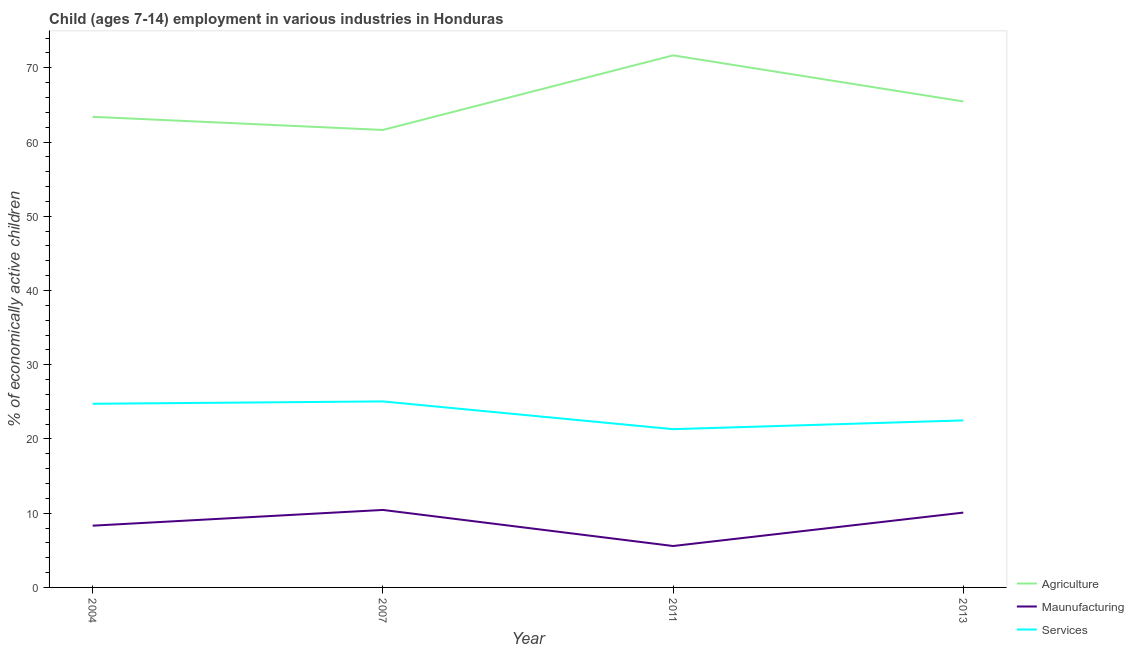How many different coloured lines are there?
Offer a very short reply. 3. Is the number of lines equal to the number of legend labels?
Your response must be concise. Yes. What is the percentage of economically active children in agriculture in 2011?
Offer a terse response. 71.68. Across all years, what is the maximum percentage of economically active children in manufacturing?
Your answer should be compact. 10.44. Across all years, what is the minimum percentage of economically active children in services?
Provide a succinct answer. 21.32. In which year was the percentage of economically active children in agriculture minimum?
Give a very brief answer. 2007. What is the total percentage of economically active children in agriculture in the graph?
Offer a very short reply. 262.18. What is the difference between the percentage of economically active children in services in 2007 and that in 2013?
Offer a terse response. 2.56. What is the difference between the percentage of economically active children in services in 2011 and the percentage of economically active children in agriculture in 2004?
Ensure brevity in your answer.  -42.08. What is the average percentage of economically active children in services per year?
Keep it short and to the point. 23.41. In the year 2011, what is the difference between the percentage of economically active children in manufacturing and percentage of economically active children in services?
Provide a succinct answer. -15.74. In how many years, is the percentage of economically active children in services greater than 18 %?
Ensure brevity in your answer.  4. What is the ratio of the percentage of economically active children in manufacturing in 2004 to that in 2011?
Ensure brevity in your answer.  1.49. What is the difference between the highest and the second highest percentage of economically active children in agriculture?
Provide a short and direct response. 6.21. What is the difference between the highest and the lowest percentage of economically active children in agriculture?
Ensure brevity in your answer.  10.05. In how many years, is the percentage of economically active children in manufacturing greater than the average percentage of economically active children in manufacturing taken over all years?
Your response must be concise. 2. Is it the case that in every year, the sum of the percentage of economically active children in agriculture and percentage of economically active children in manufacturing is greater than the percentage of economically active children in services?
Give a very brief answer. Yes. What is the difference between two consecutive major ticks on the Y-axis?
Make the answer very short. 10. Are the values on the major ticks of Y-axis written in scientific E-notation?
Your response must be concise. No. Does the graph contain any zero values?
Offer a terse response. No. How are the legend labels stacked?
Your response must be concise. Vertical. What is the title of the graph?
Make the answer very short. Child (ages 7-14) employment in various industries in Honduras. Does "Agriculture" appear as one of the legend labels in the graph?
Your response must be concise. Yes. What is the label or title of the Y-axis?
Your answer should be compact. % of economically active children. What is the % of economically active children of Agriculture in 2004?
Your response must be concise. 63.4. What is the % of economically active children of Maunufacturing in 2004?
Offer a terse response. 8.32. What is the % of economically active children of Services in 2004?
Ensure brevity in your answer.  24.74. What is the % of economically active children in Agriculture in 2007?
Give a very brief answer. 61.63. What is the % of economically active children in Maunufacturing in 2007?
Ensure brevity in your answer.  10.44. What is the % of economically active children of Services in 2007?
Provide a short and direct response. 25.06. What is the % of economically active children of Agriculture in 2011?
Your answer should be very brief. 71.68. What is the % of economically active children of Maunufacturing in 2011?
Provide a succinct answer. 5.58. What is the % of economically active children in Services in 2011?
Make the answer very short. 21.32. What is the % of economically active children in Agriculture in 2013?
Your answer should be compact. 65.47. What is the % of economically active children of Maunufacturing in 2013?
Offer a terse response. 10.08. Across all years, what is the maximum % of economically active children of Agriculture?
Keep it short and to the point. 71.68. Across all years, what is the maximum % of economically active children in Maunufacturing?
Your answer should be very brief. 10.44. Across all years, what is the maximum % of economically active children in Services?
Keep it short and to the point. 25.06. Across all years, what is the minimum % of economically active children of Agriculture?
Ensure brevity in your answer.  61.63. Across all years, what is the minimum % of economically active children of Maunufacturing?
Make the answer very short. 5.58. Across all years, what is the minimum % of economically active children of Services?
Provide a short and direct response. 21.32. What is the total % of economically active children of Agriculture in the graph?
Give a very brief answer. 262.18. What is the total % of economically active children in Maunufacturing in the graph?
Offer a very short reply. 34.42. What is the total % of economically active children of Services in the graph?
Ensure brevity in your answer.  93.62. What is the difference between the % of economically active children in Agriculture in 2004 and that in 2007?
Provide a short and direct response. 1.77. What is the difference between the % of economically active children in Maunufacturing in 2004 and that in 2007?
Make the answer very short. -2.12. What is the difference between the % of economically active children of Services in 2004 and that in 2007?
Provide a short and direct response. -0.32. What is the difference between the % of economically active children in Agriculture in 2004 and that in 2011?
Provide a short and direct response. -8.28. What is the difference between the % of economically active children in Maunufacturing in 2004 and that in 2011?
Make the answer very short. 2.74. What is the difference between the % of economically active children of Services in 2004 and that in 2011?
Keep it short and to the point. 3.42. What is the difference between the % of economically active children in Agriculture in 2004 and that in 2013?
Your answer should be very brief. -2.07. What is the difference between the % of economically active children of Maunufacturing in 2004 and that in 2013?
Keep it short and to the point. -1.76. What is the difference between the % of economically active children of Services in 2004 and that in 2013?
Make the answer very short. 2.24. What is the difference between the % of economically active children in Agriculture in 2007 and that in 2011?
Offer a very short reply. -10.05. What is the difference between the % of economically active children in Maunufacturing in 2007 and that in 2011?
Your response must be concise. 4.86. What is the difference between the % of economically active children of Services in 2007 and that in 2011?
Offer a very short reply. 3.74. What is the difference between the % of economically active children in Agriculture in 2007 and that in 2013?
Provide a short and direct response. -3.84. What is the difference between the % of economically active children of Maunufacturing in 2007 and that in 2013?
Make the answer very short. 0.36. What is the difference between the % of economically active children in Services in 2007 and that in 2013?
Keep it short and to the point. 2.56. What is the difference between the % of economically active children in Agriculture in 2011 and that in 2013?
Your answer should be very brief. 6.21. What is the difference between the % of economically active children of Services in 2011 and that in 2013?
Your answer should be compact. -1.18. What is the difference between the % of economically active children in Agriculture in 2004 and the % of economically active children in Maunufacturing in 2007?
Give a very brief answer. 52.96. What is the difference between the % of economically active children in Agriculture in 2004 and the % of economically active children in Services in 2007?
Your answer should be very brief. 38.34. What is the difference between the % of economically active children of Maunufacturing in 2004 and the % of economically active children of Services in 2007?
Offer a terse response. -16.74. What is the difference between the % of economically active children in Agriculture in 2004 and the % of economically active children in Maunufacturing in 2011?
Offer a very short reply. 57.82. What is the difference between the % of economically active children in Agriculture in 2004 and the % of economically active children in Services in 2011?
Your answer should be very brief. 42.08. What is the difference between the % of economically active children of Maunufacturing in 2004 and the % of economically active children of Services in 2011?
Make the answer very short. -13. What is the difference between the % of economically active children of Agriculture in 2004 and the % of economically active children of Maunufacturing in 2013?
Your answer should be very brief. 53.32. What is the difference between the % of economically active children of Agriculture in 2004 and the % of economically active children of Services in 2013?
Offer a very short reply. 40.9. What is the difference between the % of economically active children of Maunufacturing in 2004 and the % of economically active children of Services in 2013?
Give a very brief answer. -14.18. What is the difference between the % of economically active children in Agriculture in 2007 and the % of economically active children in Maunufacturing in 2011?
Offer a very short reply. 56.05. What is the difference between the % of economically active children in Agriculture in 2007 and the % of economically active children in Services in 2011?
Your answer should be compact. 40.31. What is the difference between the % of economically active children in Maunufacturing in 2007 and the % of economically active children in Services in 2011?
Offer a terse response. -10.88. What is the difference between the % of economically active children in Agriculture in 2007 and the % of economically active children in Maunufacturing in 2013?
Offer a terse response. 51.55. What is the difference between the % of economically active children in Agriculture in 2007 and the % of economically active children in Services in 2013?
Offer a terse response. 39.13. What is the difference between the % of economically active children of Maunufacturing in 2007 and the % of economically active children of Services in 2013?
Provide a succinct answer. -12.06. What is the difference between the % of economically active children of Agriculture in 2011 and the % of economically active children of Maunufacturing in 2013?
Offer a terse response. 61.6. What is the difference between the % of economically active children of Agriculture in 2011 and the % of economically active children of Services in 2013?
Provide a succinct answer. 49.18. What is the difference between the % of economically active children in Maunufacturing in 2011 and the % of economically active children in Services in 2013?
Provide a short and direct response. -16.92. What is the average % of economically active children of Agriculture per year?
Give a very brief answer. 65.55. What is the average % of economically active children in Maunufacturing per year?
Offer a very short reply. 8.61. What is the average % of economically active children of Services per year?
Give a very brief answer. 23.41. In the year 2004, what is the difference between the % of economically active children of Agriculture and % of economically active children of Maunufacturing?
Provide a short and direct response. 55.08. In the year 2004, what is the difference between the % of economically active children of Agriculture and % of economically active children of Services?
Give a very brief answer. 38.66. In the year 2004, what is the difference between the % of economically active children in Maunufacturing and % of economically active children in Services?
Offer a terse response. -16.42. In the year 2007, what is the difference between the % of economically active children in Agriculture and % of economically active children in Maunufacturing?
Provide a succinct answer. 51.19. In the year 2007, what is the difference between the % of economically active children of Agriculture and % of economically active children of Services?
Your answer should be very brief. 36.57. In the year 2007, what is the difference between the % of economically active children in Maunufacturing and % of economically active children in Services?
Keep it short and to the point. -14.62. In the year 2011, what is the difference between the % of economically active children in Agriculture and % of economically active children in Maunufacturing?
Offer a terse response. 66.1. In the year 2011, what is the difference between the % of economically active children of Agriculture and % of economically active children of Services?
Provide a succinct answer. 50.36. In the year 2011, what is the difference between the % of economically active children of Maunufacturing and % of economically active children of Services?
Your answer should be compact. -15.74. In the year 2013, what is the difference between the % of economically active children of Agriculture and % of economically active children of Maunufacturing?
Offer a very short reply. 55.39. In the year 2013, what is the difference between the % of economically active children in Agriculture and % of economically active children in Services?
Your answer should be compact. 42.97. In the year 2013, what is the difference between the % of economically active children of Maunufacturing and % of economically active children of Services?
Ensure brevity in your answer.  -12.42. What is the ratio of the % of economically active children in Agriculture in 2004 to that in 2007?
Your answer should be very brief. 1.03. What is the ratio of the % of economically active children of Maunufacturing in 2004 to that in 2007?
Your answer should be compact. 0.8. What is the ratio of the % of economically active children in Services in 2004 to that in 2007?
Give a very brief answer. 0.99. What is the ratio of the % of economically active children in Agriculture in 2004 to that in 2011?
Give a very brief answer. 0.88. What is the ratio of the % of economically active children in Maunufacturing in 2004 to that in 2011?
Provide a succinct answer. 1.49. What is the ratio of the % of economically active children of Services in 2004 to that in 2011?
Your answer should be very brief. 1.16. What is the ratio of the % of economically active children of Agriculture in 2004 to that in 2013?
Make the answer very short. 0.97. What is the ratio of the % of economically active children in Maunufacturing in 2004 to that in 2013?
Give a very brief answer. 0.83. What is the ratio of the % of economically active children of Services in 2004 to that in 2013?
Your answer should be very brief. 1.1. What is the ratio of the % of economically active children of Agriculture in 2007 to that in 2011?
Keep it short and to the point. 0.86. What is the ratio of the % of economically active children in Maunufacturing in 2007 to that in 2011?
Make the answer very short. 1.87. What is the ratio of the % of economically active children in Services in 2007 to that in 2011?
Provide a short and direct response. 1.18. What is the ratio of the % of economically active children of Agriculture in 2007 to that in 2013?
Provide a succinct answer. 0.94. What is the ratio of the % of economically active children of Maunufacturing in 2007 to that in 2013?
Your answer should be compact. 1.04. What is the ratio of the % of economically active children in Services in 2007 to that in 2013?
Provide a short and direct response. 1.11. What is the ratio of the % of economically active children in Agriculture in 2011 to that in 2013?
Ensure brevity in your answer.  1.09. What is the ratio of the % of economically active children in Maunufacturing in 2011 to that in 2013?
Offer a very short reply. 0.55. What is the ratio of the % of economically active children in Services in 2011 to that in 2013?
Make the answer very short. 0.95. What is the difference between the highest and the second highest % of economically active children in Agriculture?
Your response must be concise. 6.21. What is the difference between the highest and the second highest % of economically active children of Maunufacturing?
Your answer should be very brief. 0.36. What is the difference between the highest and the second highest % of economically active children of Services?
Offer a terse response. 0.32. What is the difference between the highest and the lowest % of economically active children in Agriculture?
Offer a terse response. 10.05. What is the difference between the highest and the lowest % of economically active children in Maunufacturing?
Your answer should be compact. 4.86. What is the difference between the highest and the lowest % of economically active children in Services?
Provide a short and direct response. 3.74. 